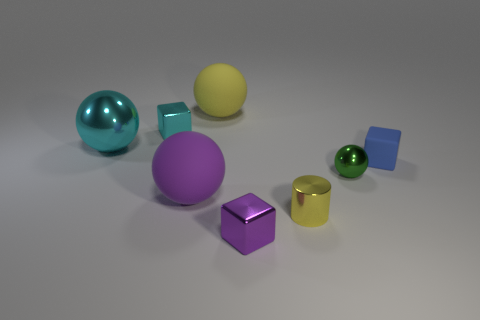Can you describe the lighting in the image? The scene is softly lit by a diffuse light source that doesn't create harsh shadows. It provides a calm atmosphere and clearly reveals the colors and shapes of the objects. 